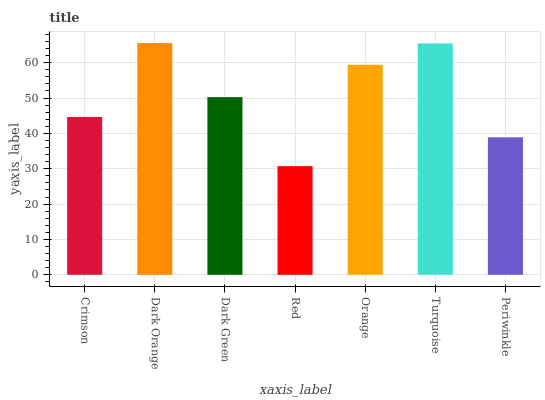Is Red the minimum?
Answer yes or no. Yes. Is Dark Orange the maximum?
Answer yes or no. Yes. Is Dark Green the minimum?
Answer yes or no. No. Is Dark Green the maximum?
Answer yes or no. No. Is Dark Orange greater than Dark Green?
Answer yes or no. Yes. Is Dark Green less than Dark Orange?
Answer yes or no. Yes. Is Dark Green greater than Dark Orange?
Answer yes or no. No. Is Dark Orange less than Dark Green?
Answer yes or no. No. Is Dark Green the high median?
Answer yes or no. Yes. Is Dark Green the low median?
Answer yes or no. Yes. Is Turquoise the high median?
Answer yes or no. No. Is Dark Orange the low median?
Answer yes or no. No. 